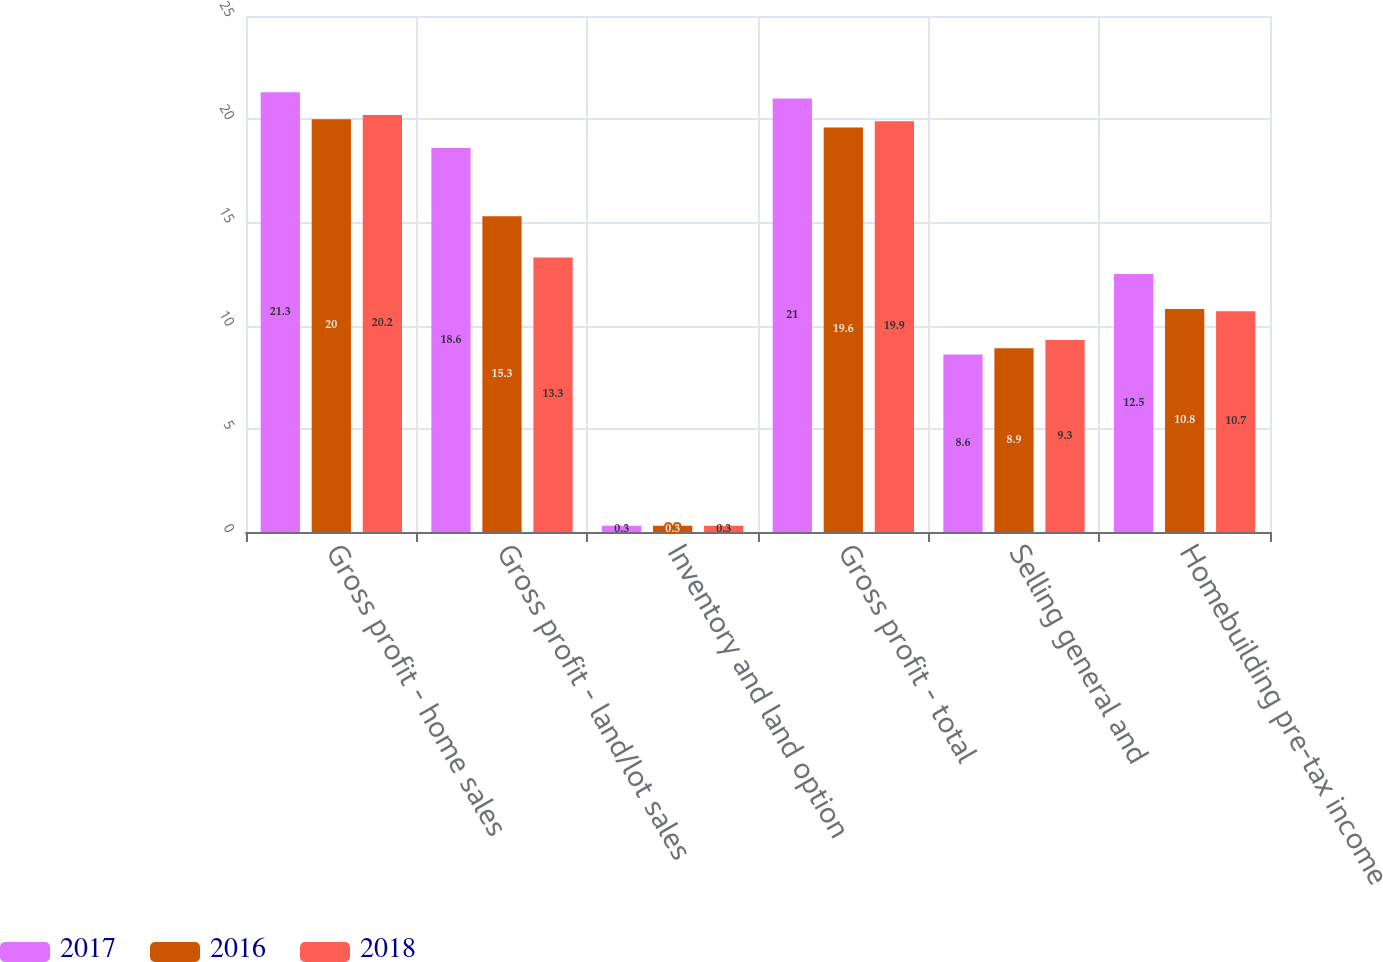Convert chart. <chart><loc_0><loc_0><loc_500><loc_500><stacked_bar_chart><ecel><fcel>Gross profit - home sales<fcel>Gross profit - land/lot sales<fcel>Inventory and land option<fcel>Gross profit - total<fcel>Selling general and<fcel>Homebuilding pre-tax income<nl><fcel>2017<fcel>21.3<fcel>18.6<fcel>0.3<fcel>21<fcel>8.6<fcel>12.5<nl><fcel>2016<fcel>20<fcel>15.3<fcel>0.3<fcel>19.6<fcel>8.9<fcel>10.8<nl><fcel>2018<fcel>20.2<fcel>13.3<fcel>0.3<fcel>19.9<fcel>9.3<fcel>10.7<nl></chart> 